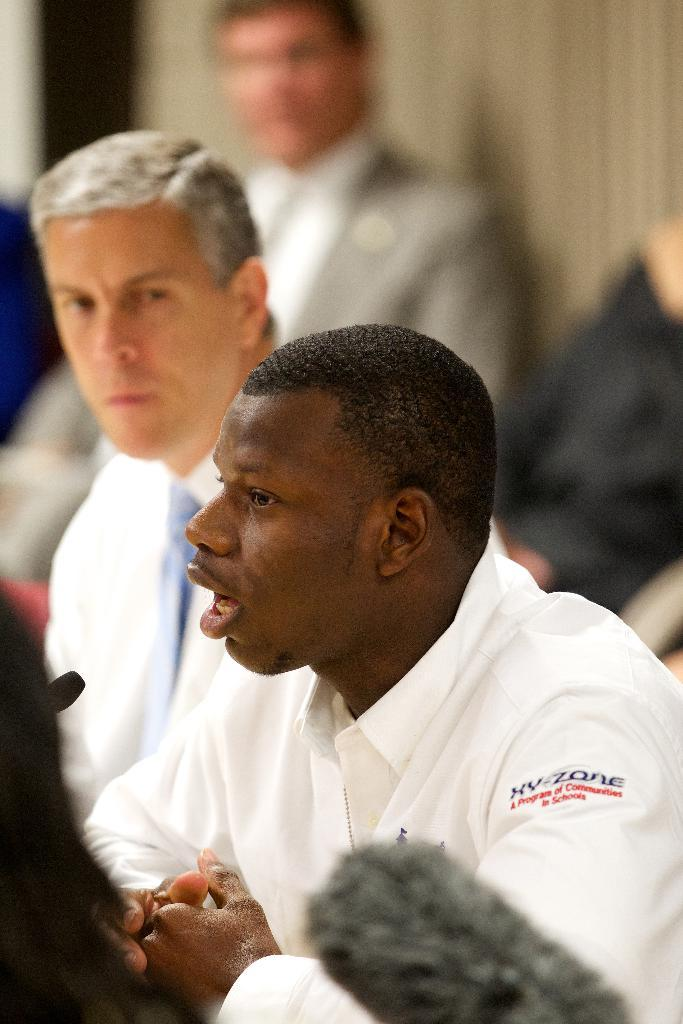What is happening in the image? There is a group of people in the image, and they are sitting. Can you describe the background of the image? The background of the image is blurred. What type of ghost can be seen interacting with the people in the image? There is no ghost present in the image; it only features a group of people sitting. What thoughts or ideas are the people in the image discussing? The image does not provide information about the thoughts or ideas being discussed by the people in the image. 